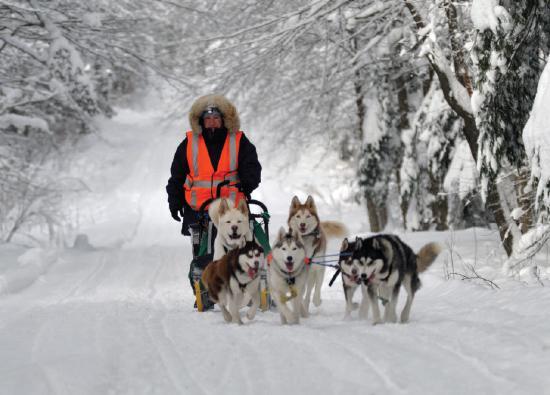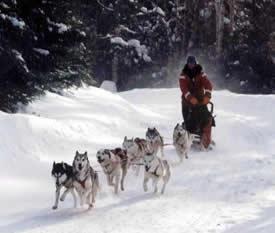The first image is the image on the left, the second image is the image on the right. Given the left and right images, does the statement "A team of sled dogs is walking on a road that has no snow on it." hold true? Answer yes or no. No. The first image is the image on the left, the second image is the image on the right. Analyze the images presented: Is the assertion "sled dogs are pulling a wagon on a dirt road" valid? Answer yes or no. No. 